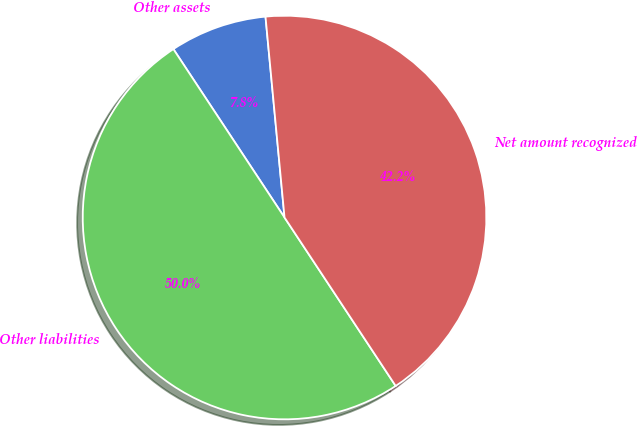<chart> <loc_0><loc_0><loc_500><loc_500><pie_chart><fcel>Other assets<fcel>Other liabilities<fcel>Net amount recognized<nl><fcel>7.78%<fcel>50.0%<fcel>42.22%<nl></chart> 